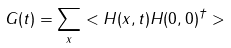Convert formula to latex. <formula><loc_0><loc_0><loc_500><loc_500>G ( t ) = \sum _ { x } < H ( x , t ) H ( 0 , 0 ) ^ { \dagger } ></formula> 